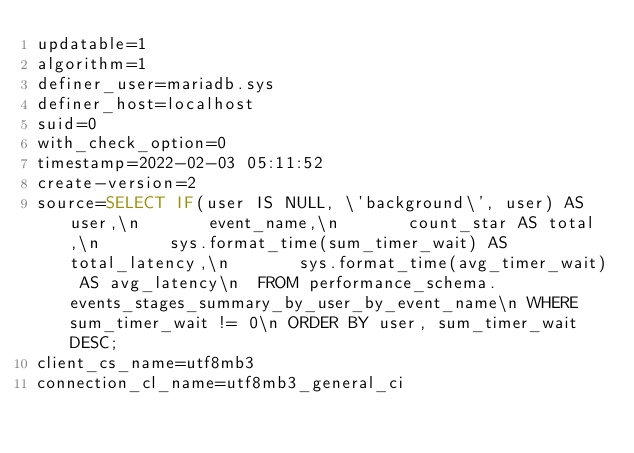Convert code to text. <code><loc_0><loc_0><loc_500><loc_500><_VisualBasic_>updatable=1
algorithm=1
definer_user=mariadb.sys
definer_host=localhost
suid=0
with_check_option=0
timestamp=2022-02-03 05:11:52
create-version=2
source=SELECT IF(user IS NULL, \'background\', user) AS user,\n       event_name,\n       count_star AS total,\n       sys.format_time(sum_timer_wait) AS total_latency,\n       sys.format_time(avg_timer_wait) AS avg_latency\n  FROM performance_schema.events_stages_summary_by_user_by_event_name\n WHERE sum_timer_wait != 0\n ORDER BY user, sum_timer_wait DESC;
client_cs_name=utf8mb3
connection_cl_name=utf8mb3_general_ci</code> 